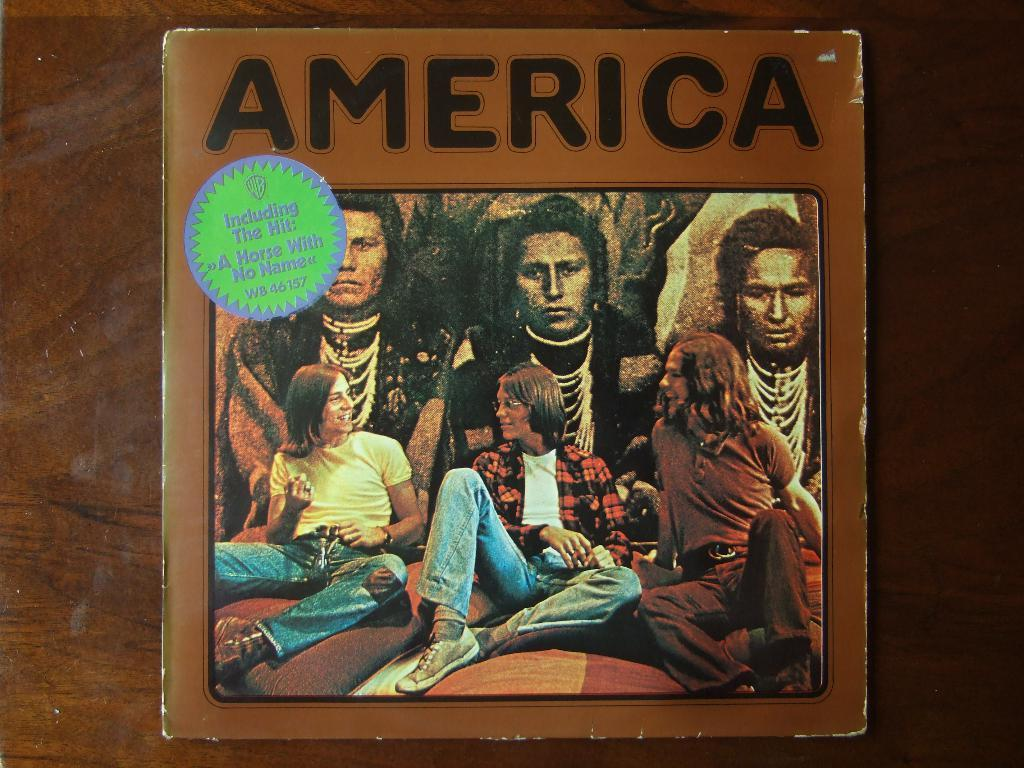<image>
Create a compact narrative representing the image presented. A vinyl copy of America's record that includes a horse with no name. 